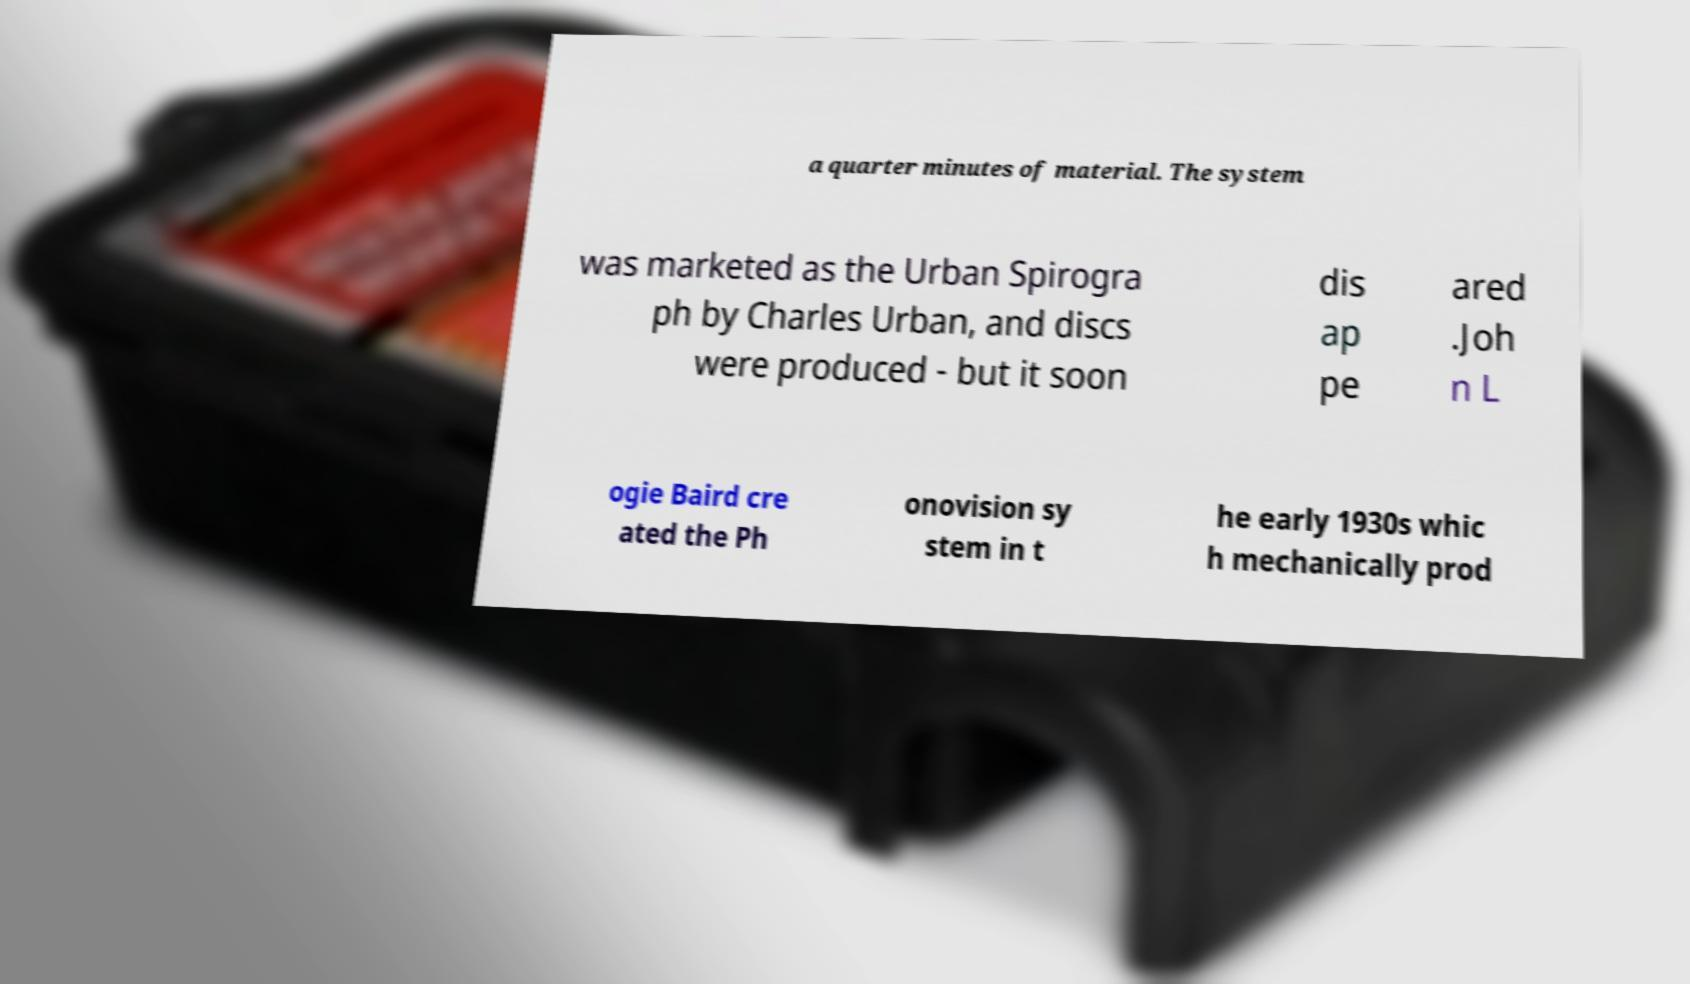Could you extract and type out the text from this image? a quarter minutes of material. The system was marketed as the Urban Spirogra ph by Charles Urban, and discs were produced - but it soon dis ap pe ared .Joh n L ogie Baird cre ated the Ph onovision sy stem in t he early 1930s whic h mechanically prod 